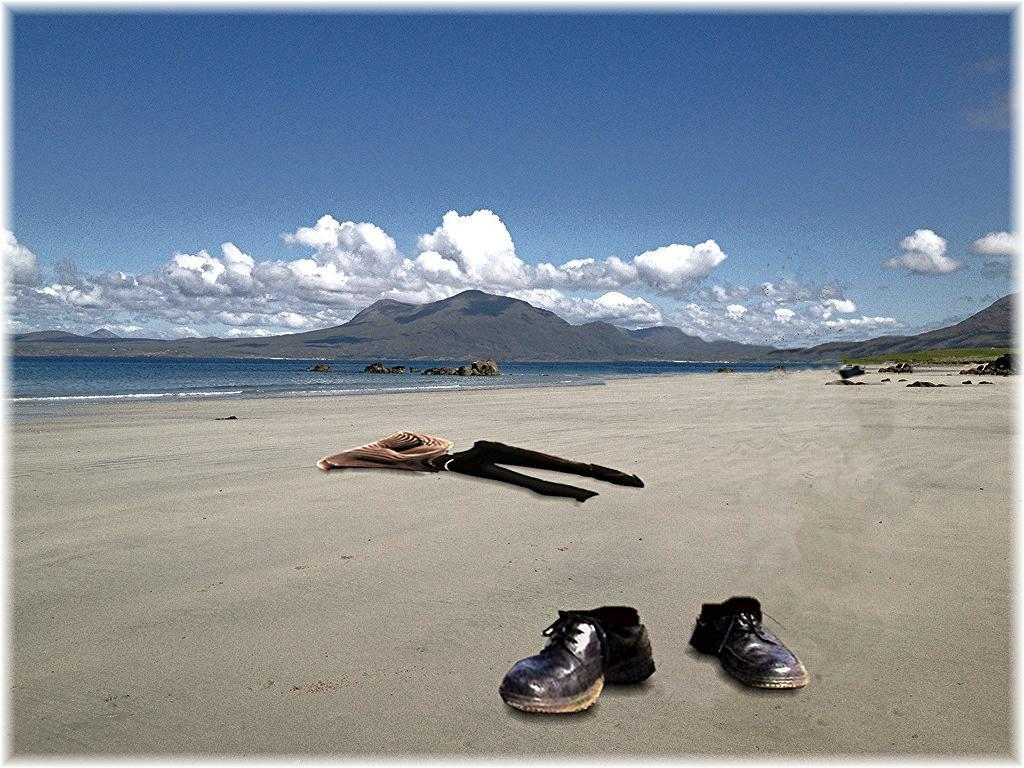What objects are on the surface of the sand in the image? There are shoes and clothes on the surface of the sand in the image. What can be seen in the background of the image? There is water and mountains visible in the background of the image. How many beds are visible in the image? There are no beds present in the image. What type of clouds can be seen in the image? There are no clouds visible in the image. 